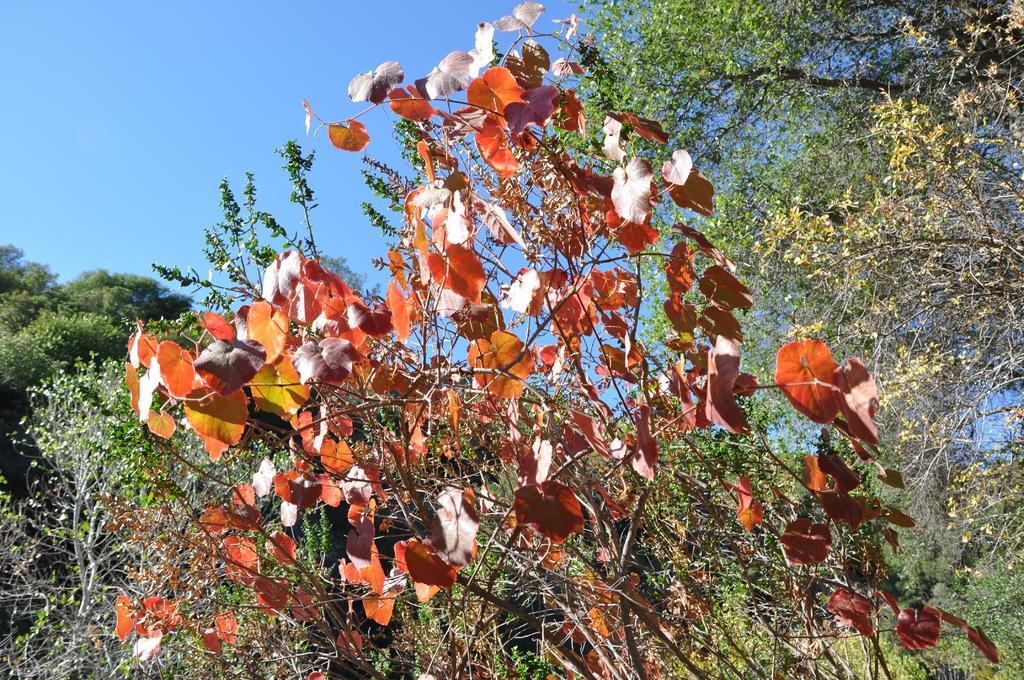How would you summarize this image in a sentence or two? In this image I can see trees and the sky in the background. 